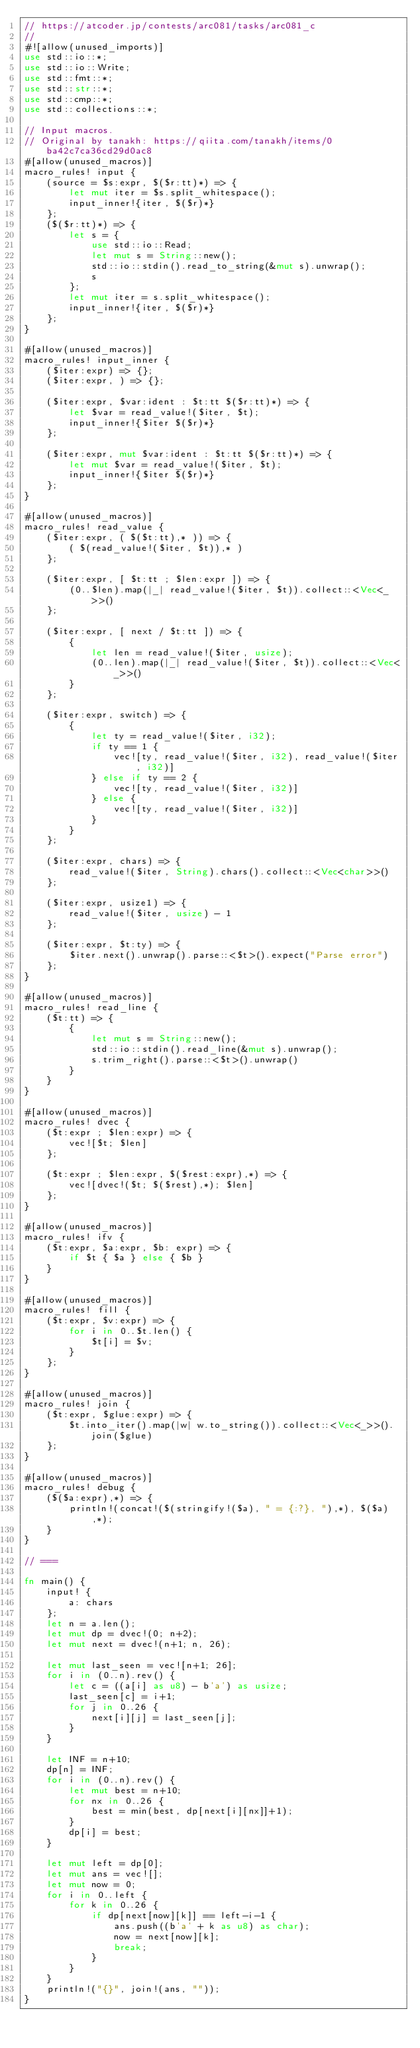Convert code to text. <code><loc_0><loc_0><loc_500><loc_500><_Rust_>// https://atcoder.jp/contests/arc081/tasks/arc081_c
//
#![allow(unused_imports)]
use std::io::*;
use std::io::Write;
use std::fmt::*;
use std::str::*;
use std::cmp::*;
use std::collections::*;

// Input macros.
// Original by tanakh: https://qiita.com/tanakh/items/0ba42c7ca36cd29d0ac8
#[allow(unused_macros)]
macro_rules! input {
    (source = $s:expr, $($r:tt)*) => {
        let mut iter = $s.split_whitespace();
        input_inner!{iter, $($r)*}
    };
    ($($r:tt)*) => {
        let s = {
            use std::io::Read;
            let mut s = String::new();
            std::io::stdin().read_to_string(&mut s).unwrap();
            s
        };
        let mut iter = s.split_whitespace();
        input_inner!{iter, $($r)*}
    };
}

#[allow(unused_macros)]
macro_rules! input_inner {
    ($iter:expr) => {};
    ($iter:expr, ) => {};

    ($iter:expr, $var:ident : $t:tt $($r:tt)*) => {
        let $var = read_value!($iter, $t);
        input_inner!{$iter $($r)*}
    };

    ($iter:expr, mut $var:ident : $t:tt $($r:tt)*) => {
        let mut $var = read_value!($iter, $t);
        input_inner!{$iter $($r)*}
    };
}

#[allow(unused_macros)]
macro_rules! read_value {
    ($iter:expr, ( $($t:tt),* )) => {
        ( $(read_value!($iter, $t)),* )
    };

    ($iter:expr, [ $t:tt ; $len:expr ]) => {
        (0..$len).map(|_| read_value!($iter, $t)).collect::<Vec<_>>()
    };

    ($iter:expr, [ next / $t:tt ]) => {
        {
            let len = read_value!($iter, usize);
            (0..len).map(|_| read_value!($iter, $t)).collect::<Vec<_>>()
        }
    };

    ($iter:expr, switch) => {
        {
            let ty = read_value!($iter, i32);
            if ty == 1 {
                vec![ty, read_value!($iter, i32), read_value!($iter, i32)]
            } else if ty == 2 {
                vec![ty, read_value!($iter, i32)]
            } else {
                vec![ty, read_value!($iter, i32)]
            }
        }
    };

    ($iter:expr, chars) => {
        read_value!($iter, String).chars().collect::<Vec<char>>()
    };

    ($iter:expr, usize1) => {
        read_value!($iter, usize) - 1
    };

    ($iter:expr, $t:ty) => {
        $iter.next().unwrap().parse::<$t>().expect("Parse error")
    };
}

#[allow(unused_macros)]
macro_rules! read_line {
    ($t:tt) => {
        {
            let mut s = String::new();
            std::io::stdin().read_line(&mut s).unwrap();
            s.trim_right().parse::<$t>().unwrap()
        }
    }
}

#[allow(unused_macros)]
macro_rules! dvec {
    ($t:expr ; $len:expr) => {
        vec![$t; $len]
    };

    ($t:expr ; $len:expr, $($rest:expr),*) => {
        vec![dvec!($t; $($rest),*); $len]
    };
}

#[allow(unused_macros)]
macro_rules! ifv {
    ($t:expr, $a:expr, $b: expr) => {
        if $t { $a } else { $b }
    }
}

#[allow(unused_macros)]
macro_rules! fill {
    ($t:expr, $v:expr) => {
        for i in 0..$t.len() {
            $t[i] = $v;
        }
    };
}

#[allow(unused_macros)]
macro_rules! join {
    ($t:expr, $glue:expr) => {
        $t.into_iter().map(|w| w.to_string()).collect::<Vec<_>>().join($glue)
    };
}

#[allow(unused_macros)]
macro_rules! debug {
    ($($a:expr),*) => {
        println!(concat!($(stringify!($a), " = {:?}, "),*), $($a),*);
    }
}

// ===

fn main() {
    input! {
        a: chars
    };
    let n = a.len();
    let mut dp = dvec!(0; n+2);
    let mut next = dvec!(n+1; n, 26);

    let mut last_seen = vec![n+1; 26];
    for i in (0..n).rev() {
        let c = ((a[i] as u8) - b'a') as usize;
        last_seen[c] = i+1;
        for j in 0..26 {
            next[i][j] = last_seen[j];
        }
    }

    let INF = n+10;
    dp[n] = INF;
    for i in (0..n).rev() {
        let mut best = n+10;
        for nx in 0..26 {
            best = min(best, dp[next[i][nx]]+1);
        }
        dp[i] = best;
    }

    let mut left = dp[0];
    let mut ans = vec![];
    let mut now = 0;
    for i in 0..left {
        for k in 0..26 {
            if dp[next[now][k]] == left-i-1 {
                ans.push((b'a' + k as u8) as char);
                now = next[now][k];
                break;
            }
        }
    }
    println!("{}", join!(ans, ""));
}
</code> 